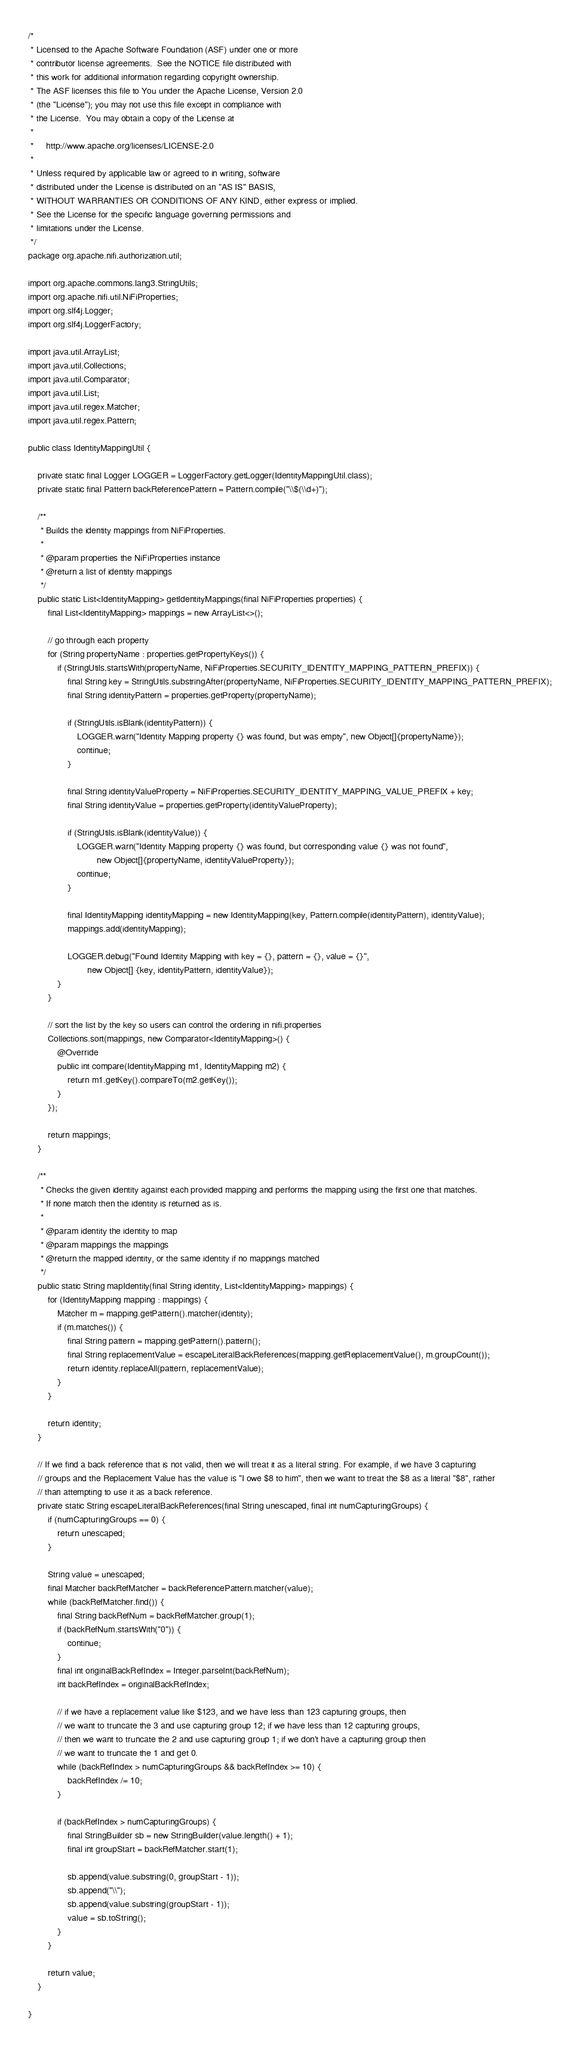Convert code to text. <code><loc_0><loc_0><loc_500><loc_500><_Java_>/*
 * Licensed to the Apache Software Foundation (ASF) under one or more
 * contributor license agreements.  See the NOTICE file distributed with
 * this work for additional information regarding copyright ownership.
 * The ASF licenses this file to You under the Apache License, Version 2.0
 * (the "License"); you may not use this file except in compliance with
 * the License.  You may obtain a copy of the License at
 *
 *     http://www.apache.org/licenses/LICENSE-2.0
 *
 * Unless required by applicable law or agreed to in writing, software
 * distributed under the License is distributed on an "AS IS" BASIS,
 * WITHOUT WARRANTIES OR CONDITIONS OF ANY KIND, either express or implied.
 * See the License for the specific language governing permissions and
 * limitations under the License.
 */
package org.apache.nifi.authorization.util;

import org.apache.commons.lang3.StringUtils;
import org.apache.nifi.util.NiFiProperties;
import org.slf4j.Logger;
import org.slf4j.LoggerFactory;

import java.util.ArrayList;
import java.util.Collections;
import java.util.Comparator;
import java.util.List;
import java.util.regex.Matcher;
import java.util.regex.Pattern;

public class IdentityMappingUtil {

    private static final Logger LOGGER = LoggerFactory.getLogger(IdentityMappingUtil.class);
    private static final Pattern backReferencePattern = Pattern.compile("\\$(\\d+)");

    /**
     * Builds the identity mappings from NiFiProperties.
     *
     * @param properties the NiFiProperties instance
     * @return a list of identity mappings
     */
    public static List<IdentityMapping> getIdentityMappings(final NiFiProperties properties) {
        final List<IdentityMapping> mappings = new ArrayList<>();

        // go through each property
        for (String propertyName : properties.getPropertyKeys()) {
            if (StringUtils.startsWith(propertyName, NiFiProperties.SECURITY_IDENTITY_MAPPING_PATTERN_PREFIX)) {
                final String key = StringUtils.substringAfter(propertyName, NiFiProperties.SECURITY_IDENTITY_MAPPING_PATTERN_PREFIX);
                final String identityPattern = properties.getProperty(propertyName);

                if (StringUtils.isBlank(identityPattern)) {
                    LOGGER.warn("Identity Mapping property {} was found, but was empty", new Object[]{propertyName});
                    continue;
                }

                final String identityValueProperty = NiFiProperties.SECURITY_IDENTITY_MAPPING_VALUE_PREFIX + key;
                final String identityValue = properties.getProperty(identityValueProperty);

                if (StringUtils.isBlank(identityValue)) {
                    LOGGER.warn("Identity Mapping property {} was found, but corresponding value {} was not found",
                            new Object[]{propertyName, identityValueProperty});
                    continue;
                }

                final IdentityMapping identityMapping = new IdentityMapping(key, Pattern.compile(identityPattern), identityValue);
                mappings.add(identityMapping);

                LOGGER.debug("Found Identity Mapping with key = {}, pattern = {}, value = {}",
                        new Object[] {key, identityPattern, identityValue});
            }
        }

        // sort the list by the key so users can control the ordering in nifi.properties
        Collections.sort(mappings, new Comparator<IdentityMapping>() {
            @Override
            public int compare(IdentityMapping m1, IdentityMapping m2) {
                return m1.getKey().compareTo(m2.getKey());
            }
        });

        return mappings;
    }

    /**
     * Checks the given identity against each provided mapping and performs the mapping using the first one that matches.
     * If none match then the identity is returned as is.
     *
     * @param identity the identity to map
     * @param mappings the mappings
     * @return the mapped identity, or the same identity if no mappings matched
     */
    public static String mapIdentity(final String identity, List<IdentityMapping> mappings) {
        for (IdentityMapping mapping : mappings) {
            Matcher m = mapping.getPattern().matcher(identity);
            if (m.matches()) {
                final String pattern = mapping.getPattern().pattern();
                final String replacementValue = escapeLiteralBackReferences(mapping.getReplacementValue(), m.groupCount());
                return identity.replaceAll(pattern, replacementValue);
            }
        }

        return identity;
    }

    // If we find a back reference that is not valid, then we will treat it as a literal string. For example, if we have 3 capturing
    // groups and the Replacement Value has the value is "I owe $8 to him", then we want to treat the $8 as a literal "$8", rather
    // than attempting to use it as a back reference.
    private static String escapeLiteralBackReferences(final String unescaped, final int numCapturingGroups) {
        if (numCapturingGroups == 0) {
            return unescaped;
        }

        String value = unescaped;
        final Matcher backRefMatcher = backReferencePattern.matcher(value);
        while (backRefMatcher.find()) {
            final String backRefNum = backRefMatcher.group(1);
            if (backRefNum.startsWith("0")) {
                continue;
            }
            final int originalBackRefIndex = Integer.parseInt(backRefNum);
            int backRefIndex = originalBackRefIndex;

            // if we have a replacement value like $123, and we have less than 123 capturing groups, then
            // we want to truncate the 3 and use capturing group 12; if we have less than 12 capturing groups,
            // then we want to truncate the 2 and use capturing group 1; if we don't have a capturing group then
            // we want to truncate the 1 and get 0.
            while (backRefIndex > numCapturingGroups && backRefIndex >= 10) {
                backRefIndex /= 10;
            }

            if (backRefIndex > numCapturingGroups) {
                final StringBuilder sb = new StringBuilder(value.length() + 1);
                final int groupStart = backRefMatcher.start(1);

                sb.append(value.substring(0, groupStart - 1));
                sb.append("\\");
                sb.append(value.substring(groupStart - 1));
                value = sb.toString();
            }
        }

        return value;
    }

}
</code> 